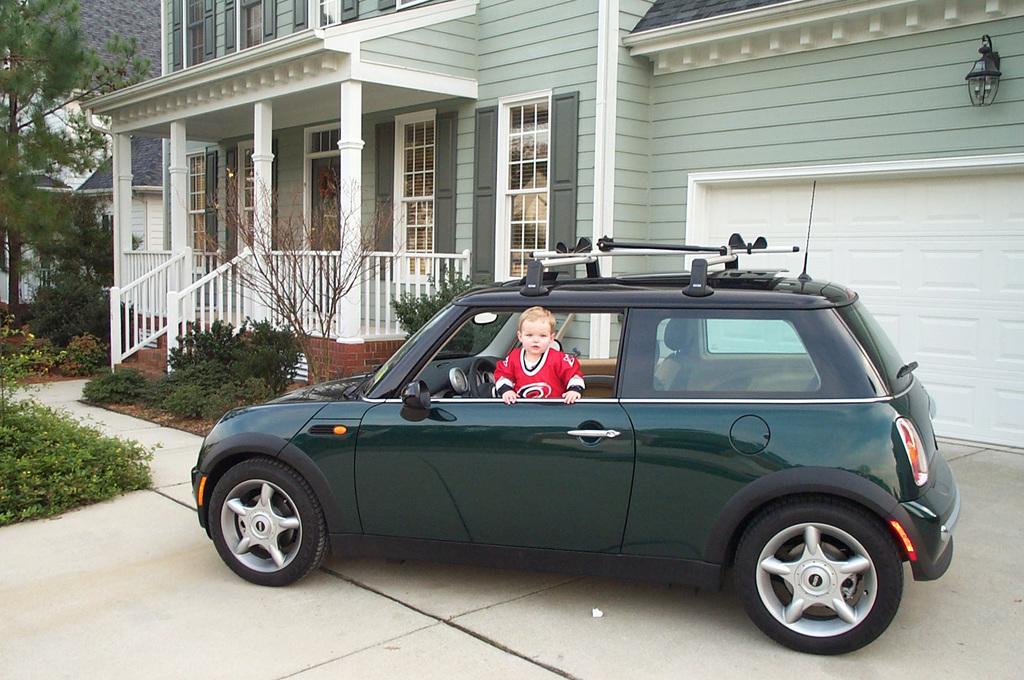Who is the main subject in the image? There is a boy in the image. What is the boy doing in the image? The boy is peeing out of a window of a car. Where is the car parked in relation to the house? The car is parked in front of a house. How many dolls are sitting on the toothbrush in the image? There are no dolls or toothbrushes present in the image. 